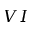<formula> <loc_0><loc_0><loc_500><loc_500>V I</formula> 